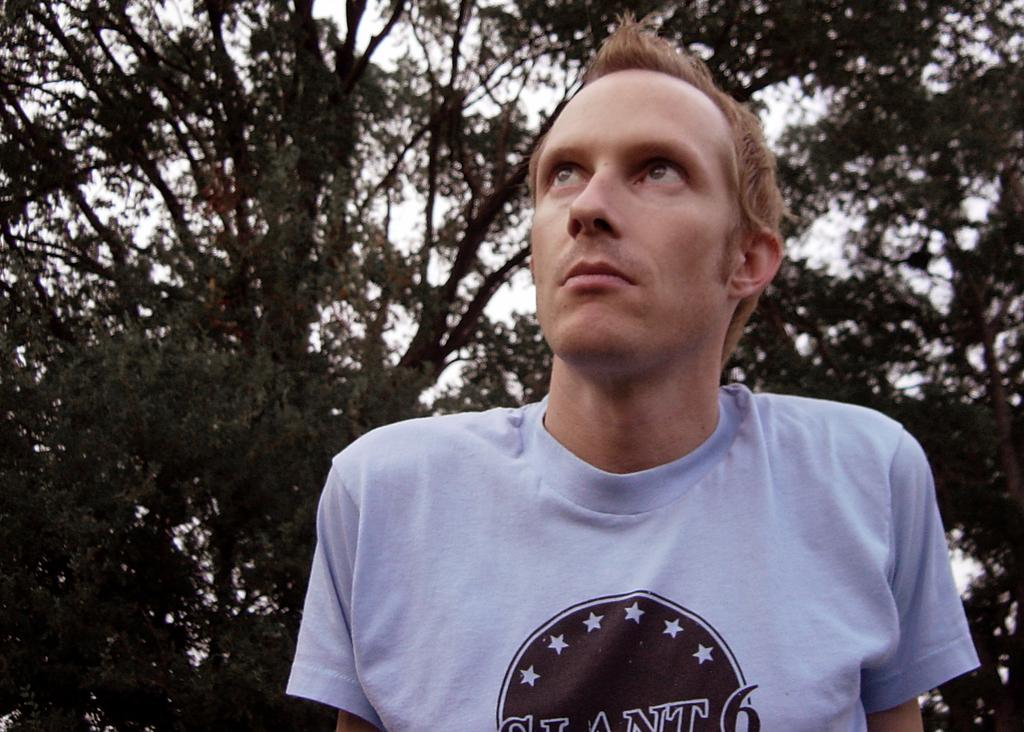What is the main subject in the foreground of the image? There is a person in the foreground of the image. What can be seen in the background of the image? There are trees and the sky visible in the background of the image. Can you see a squirrel climbing the hook and line in the image? There is no squirrel, hook, or line present in the image. 